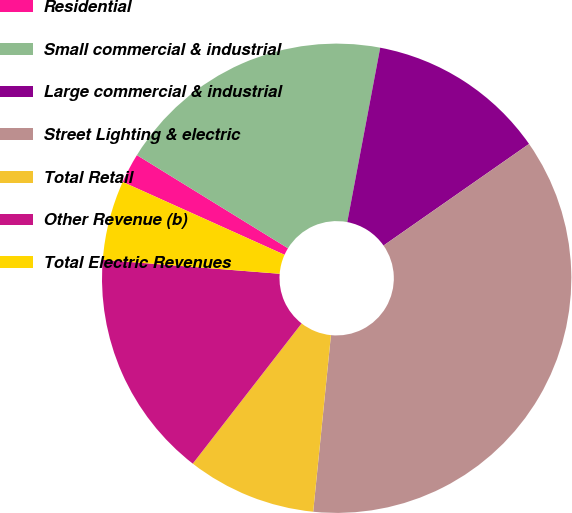Convert chart. <chart><loc_0><loc_0><loc_500><loc_500><pie_chart><fcel>Residential<fcel>Small commercial & industrial<fcel>Large commercial & industrial<fcel>Street Lighting & electric<fcel>Total Retail<fcel>Other Revenue (b)<fcel>Total Electric Revenues<nl><fcel>2.06%<fcel>19.18%<fcel>12.33%<fcel>36.3%<fcel>8.91%<fcel>15.75%<fcel>5.48%<nl></chart> 